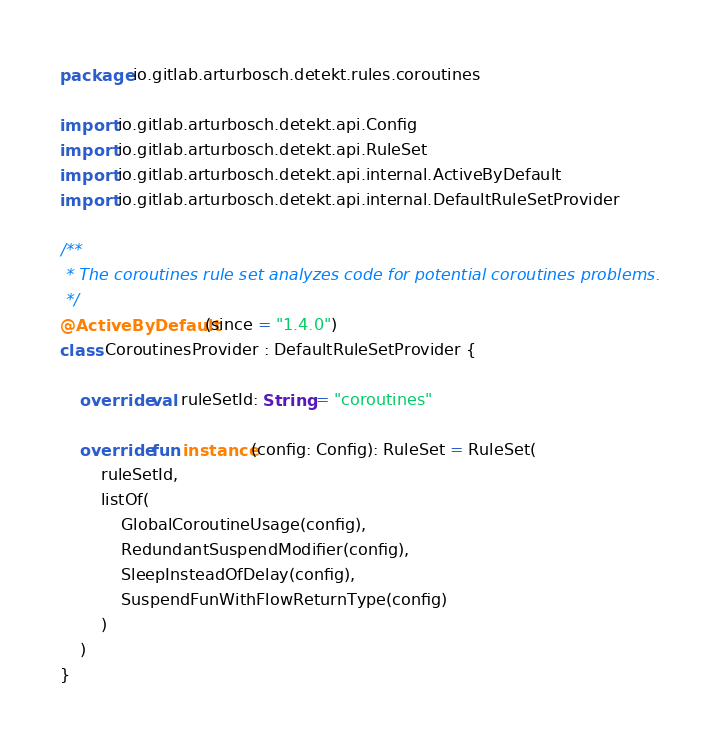<code> <loc_0><loc_0><loc_500><loc_500><_Kotlin_>package io.gitlab.arturbosch.detekt.rules.coroutines

import io.gitlab.arturbosch.detekt.api.Config
import io.gitlab.arturbosch.detekt.api.RuleSet
import io.gitlab.arturbosch.detekt.api.internal.ActiveByDefault
import io.gitlab.arturbosch.detekt.api.internal.DefaultRuleSetProvider

/**
 * The coroutines rule set analyzes code for potential coroutines problems.
 */
@ActiveByDefault(since = "1.4.0")
class CoroutinesProvider : DefaultRuleSetProvider {

    override val ruleSetId: String = "coroutines"

    override fun instance(config: Config): RuleSet = RuleSet(
        ruleSetId,
        listOf(
            GlobalCoroutineUsage(config),
            RedundantSuspendModifier(config),
            SleepInsteadOfDelay(config),
            SuspendFunWithFlowReturnType(config)
        )
    )
}
</code> 